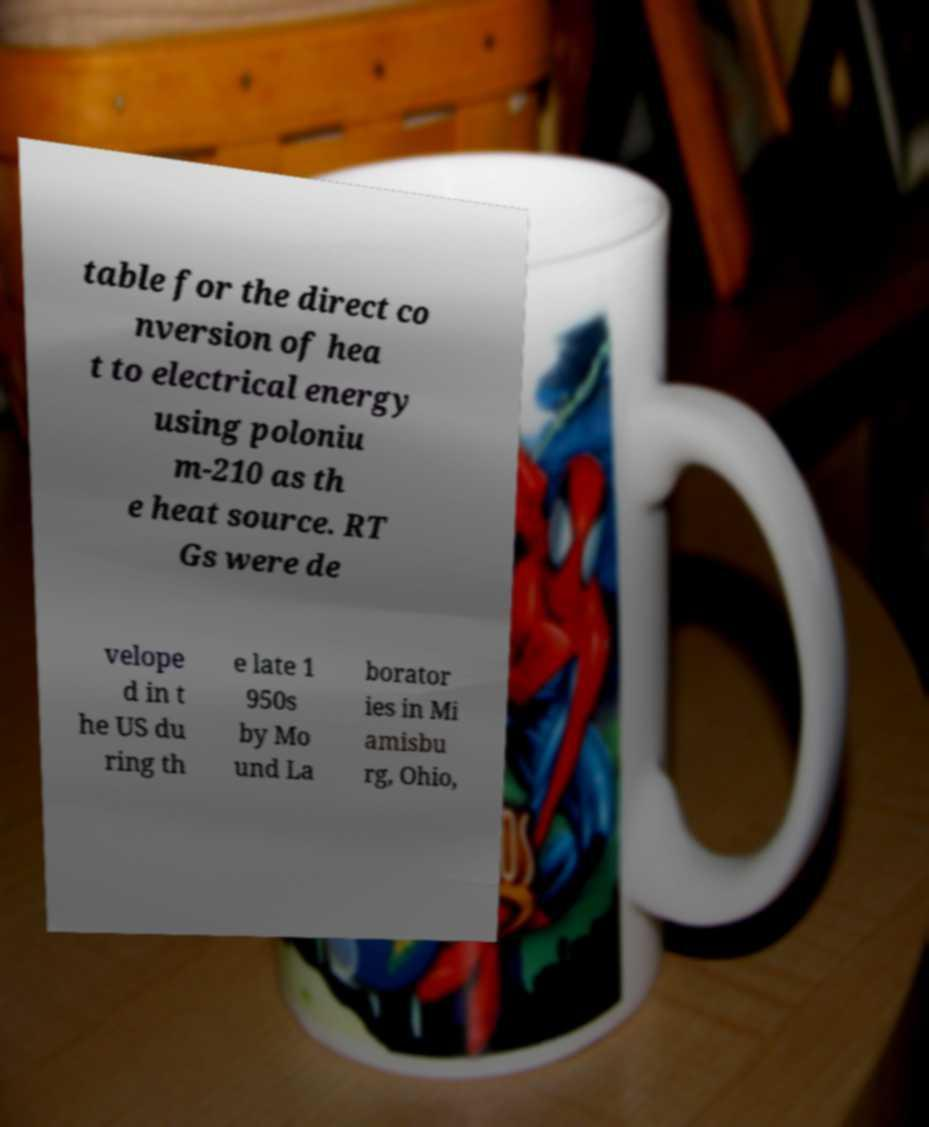For documentation purposes, I need the text within this image transcribed. Could you provide that? table for the direct co nversion of hea t to electrical energy using poloniu m-210 as th e heat source. RT Gs were de velope d in t he US du ring th e late 1 950s by Mo und La borator ies in Mi amisbu rg, Ohio, 